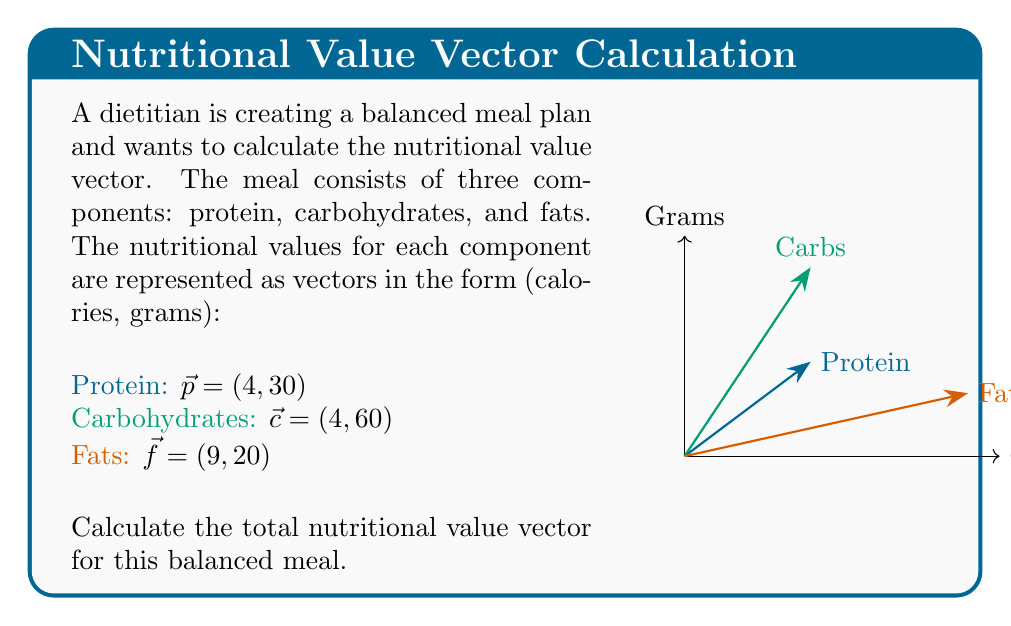Give your solution to this math problem. To calculate the total nutritional value vector, we need to add the three component vectors:

1) First, let's recall the formula for vector addition:
   $\vec{a} + \vec{b} = (a_x + b_x, a_y + b_y)$

2) In this case, we're adding three vectors:
   $\vec{total} = \vec{p} + \vec{c} + \vec{f}$

3) Let's add the x-components (calories):
   $x_{total} = 4 + 4 + 9 = 17$ calories per gram

4) Now, let's add the y-components (grams):
   $y_{total} = 30 + 60 + 20 = 110$ grams

5) Therefore, the total nutritional value vector is:
   $\vec{total} = (17, 110)$

This vector represents the total calories per gram and the total grams of the balanced meal.
Answer: $\vec{total} = (17, 110)$ 